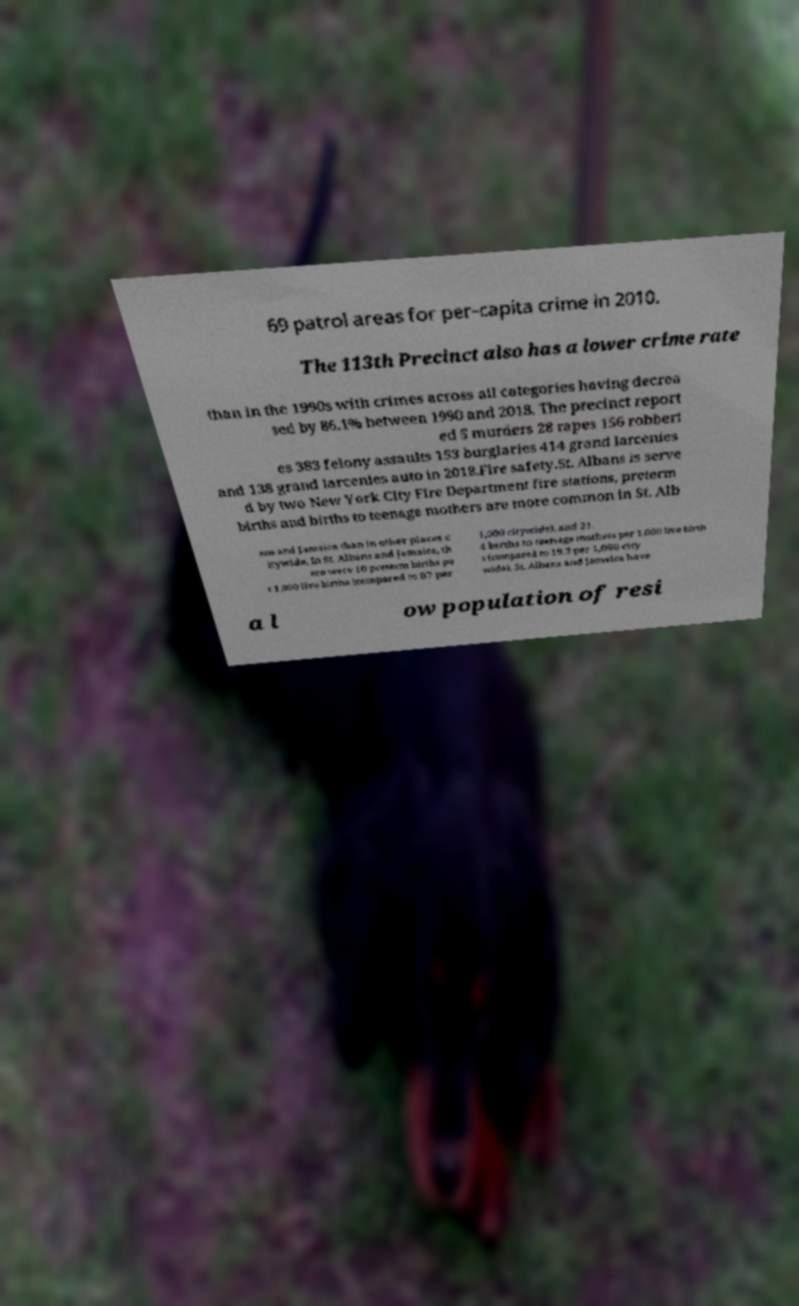There's text embedded in this image that I need extracted. Can you transcribe it verbatim? 69 patrol areas for per-capita crime in 2010. The 113th Precinct also has a lower crime rate than in the 1990s with crimes across all categories having decrea sed by 86.1% between 1990 and 2018. The precinct report ed 5 murders 28 rapes 156 robberi es 383 felony assaults 153 burglaries 414 grand larcenies and 138 grand larcenies auto in 2018.Fire safety.St. Albans is serve d by two New York City Fire Department fire stations, preterm births and births to teenage mothers are more common in St. Alb ans and Jamaica than in other places c itywide. In St. Albans and Jamaica, th ere were 10 preterm births pe r 1,000 live births (compared to 87 per 1,000 citywide), and 21. 4 births to teenage mothers per 1,000 live birth s (compared to 19.3 per 1,000 city wide). St. Albans and Jamaica have a l ow population of resi 